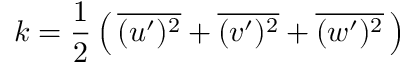Convert formula to latex. <formula><loc_0><loc_0><loc_500><loc_500>k = { \frac { 1 } { 2 } } \left ( \, { \overline { { ( u ^ { \prime } ) ^ { 2 } } } } + { \overline { { ( v ^ { \prime } ) ^ { 2 } } } } + { \overline { { ( w ^ { \prime } ) ^ { 2 } } } } \, \right )</formula> 